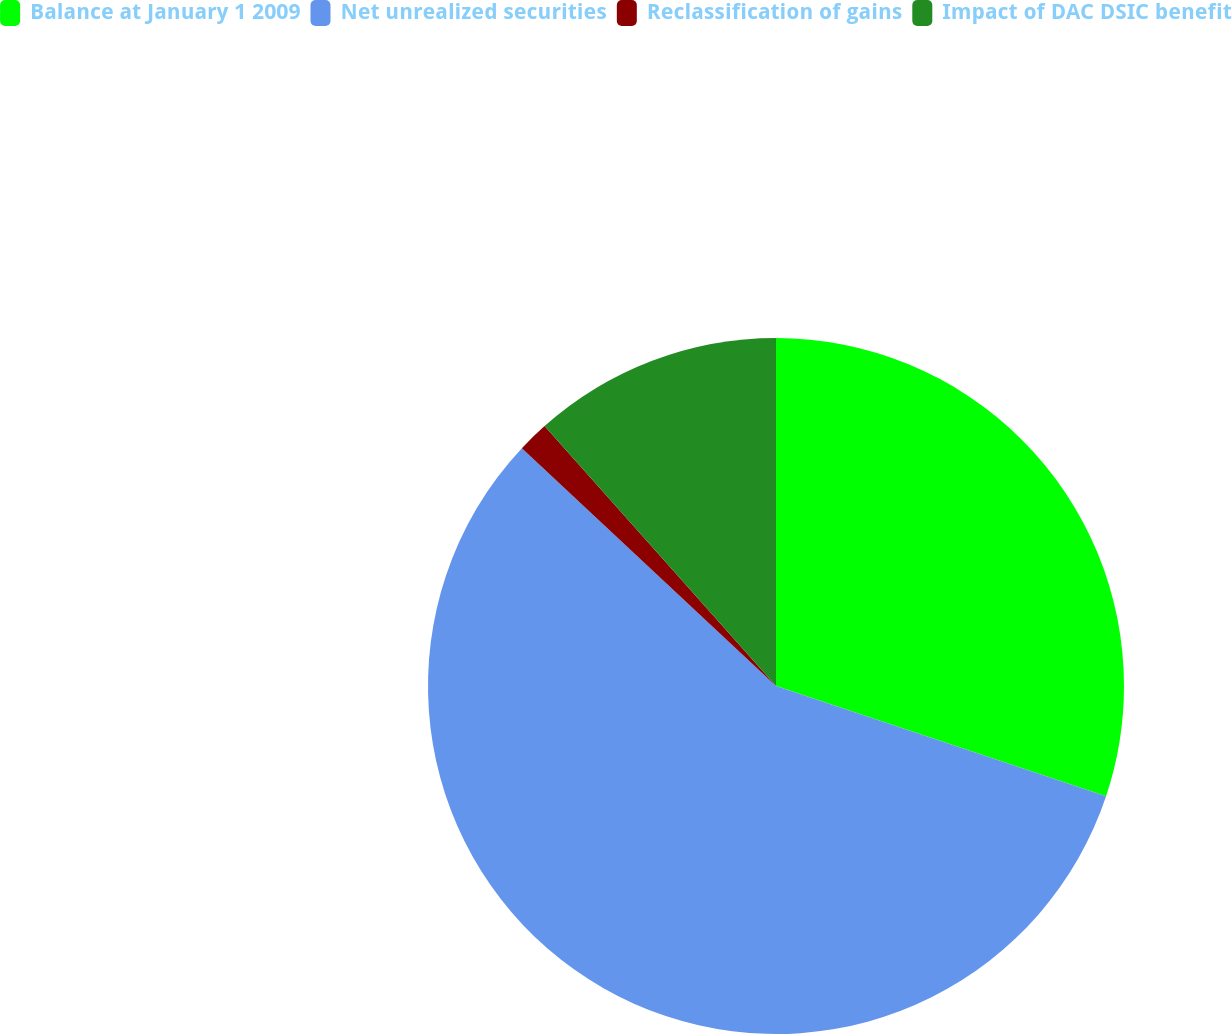<chart> <loc_0><loc_0><loc_500><loc_500><pie_chart><fcel>Balance at January 1 2009<fcel>Net unrealized securities<fcel>Reclassification of gains<fcel>Impact of DAC DSIC benefit<nl><fcel>30.13%<fcel>56.84%<fcel>1.45%<fcel>11.58%<nl></chart> 